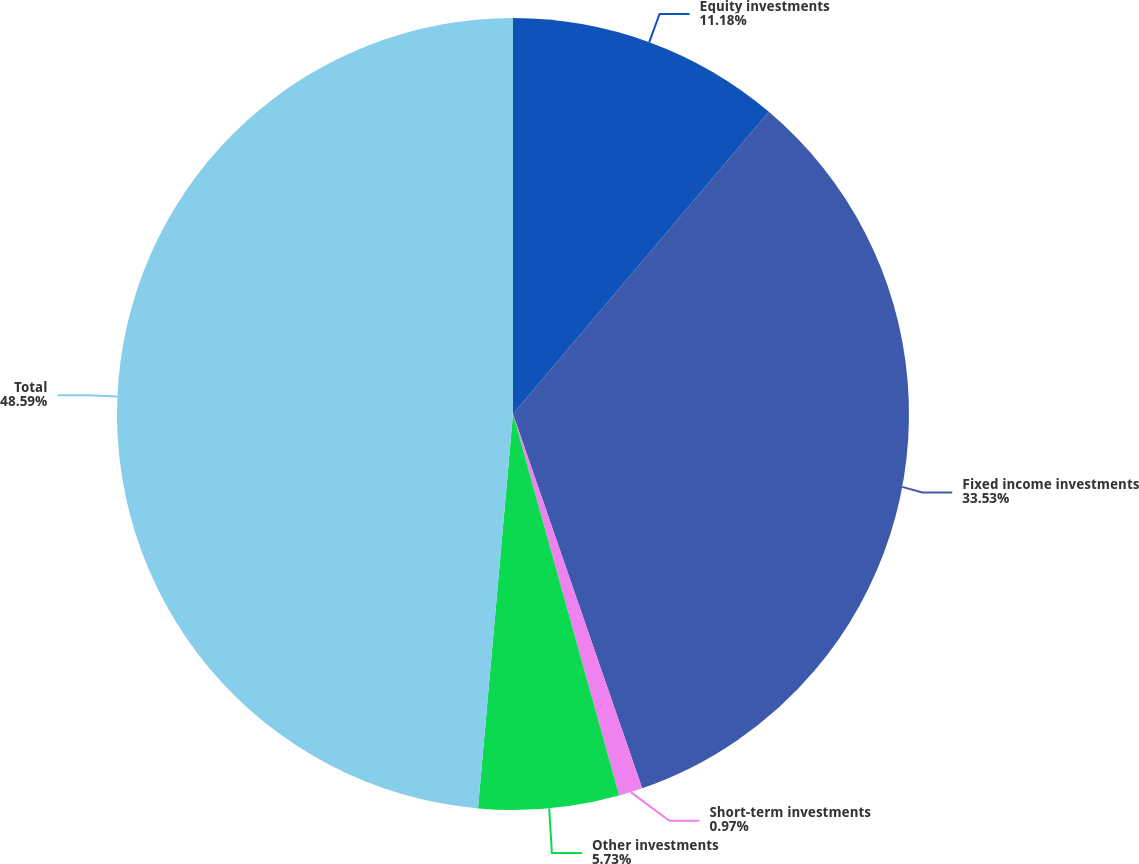<chart> <loc_0><loc_0><loc_500><loc_500><pie_chart><fcel>Equity investments<fcel>Fixed income investments<fcel>Short-term investments<fcel>Other investments<fcel>Total<nl><fcel>11.18%<fcel>33.53%<fcel>0.97%<fcel>5.73%<fcel>48.59%<nl></chart> 